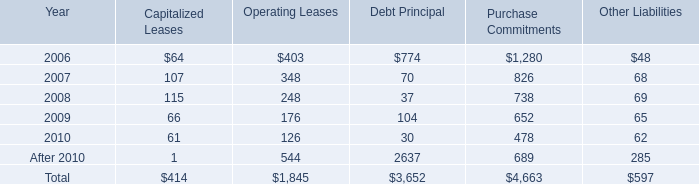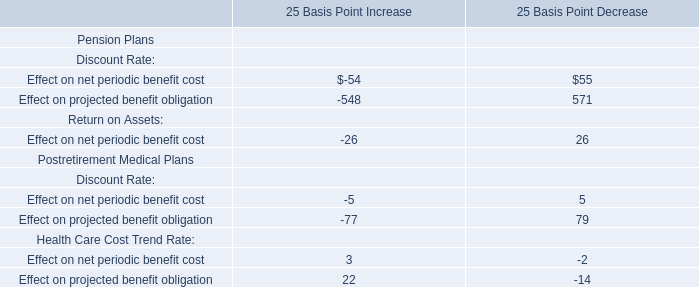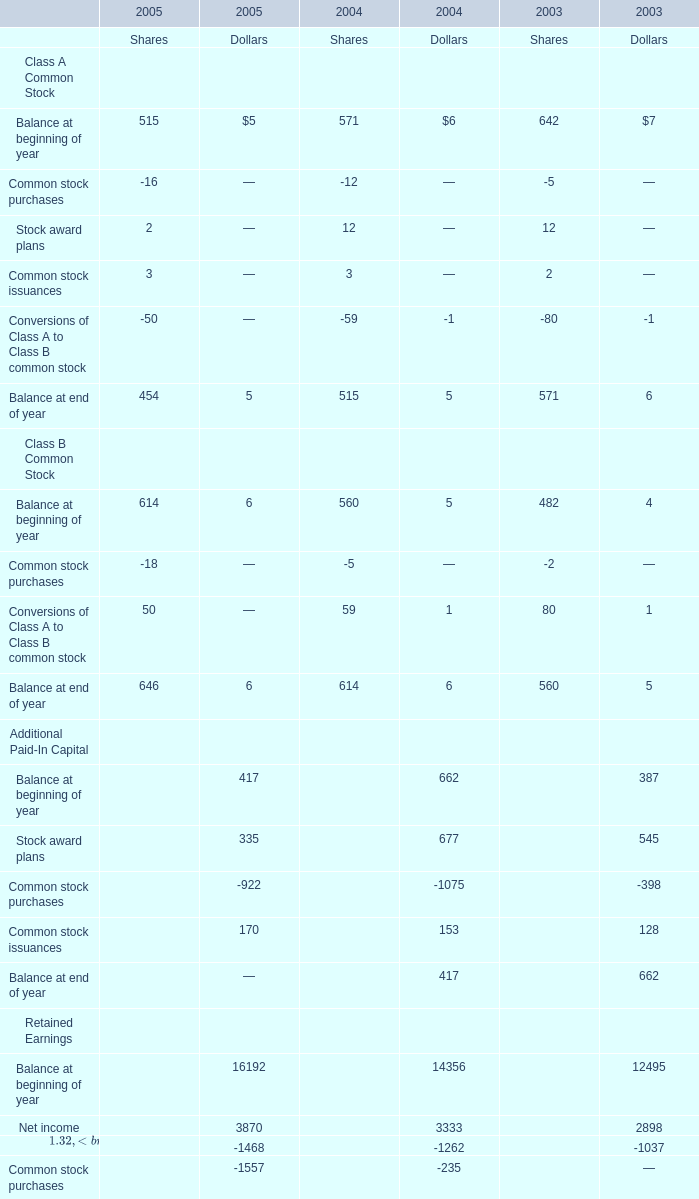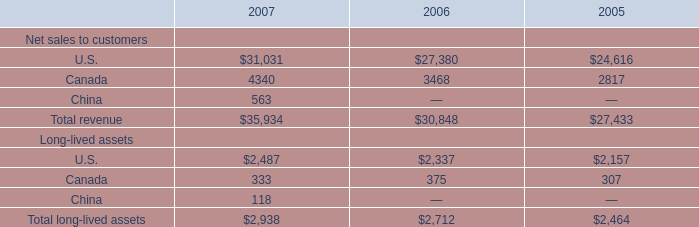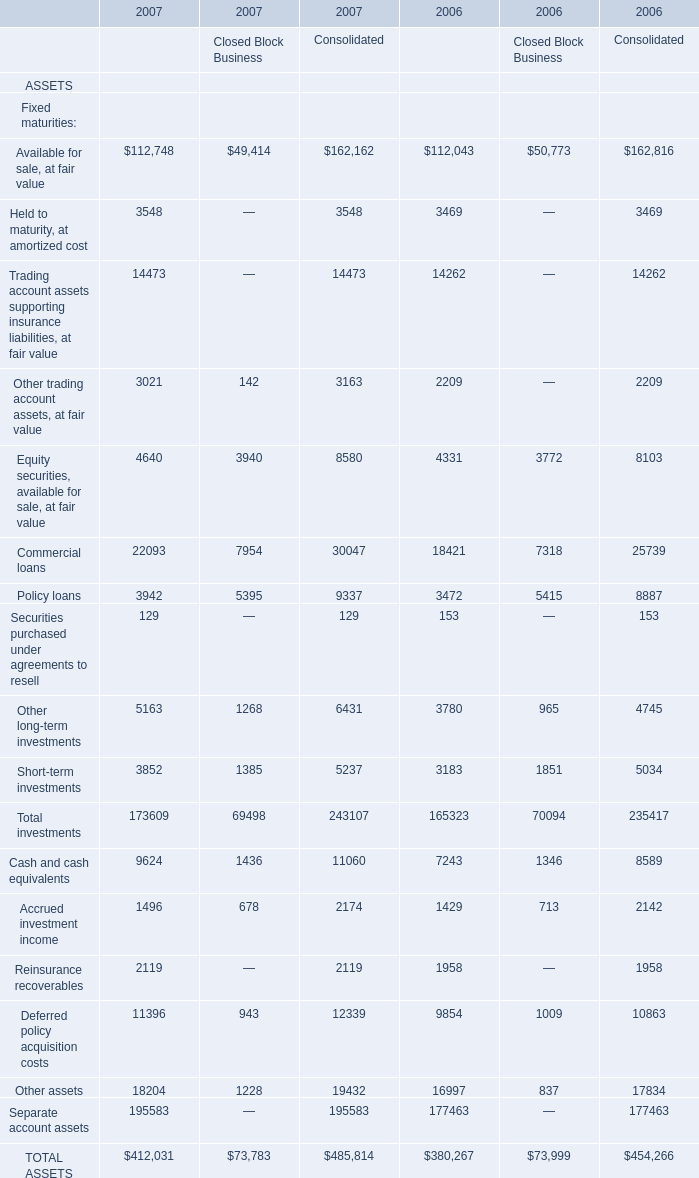How many elements show negative value in 2005 for Shares? 
Answer: 5. 